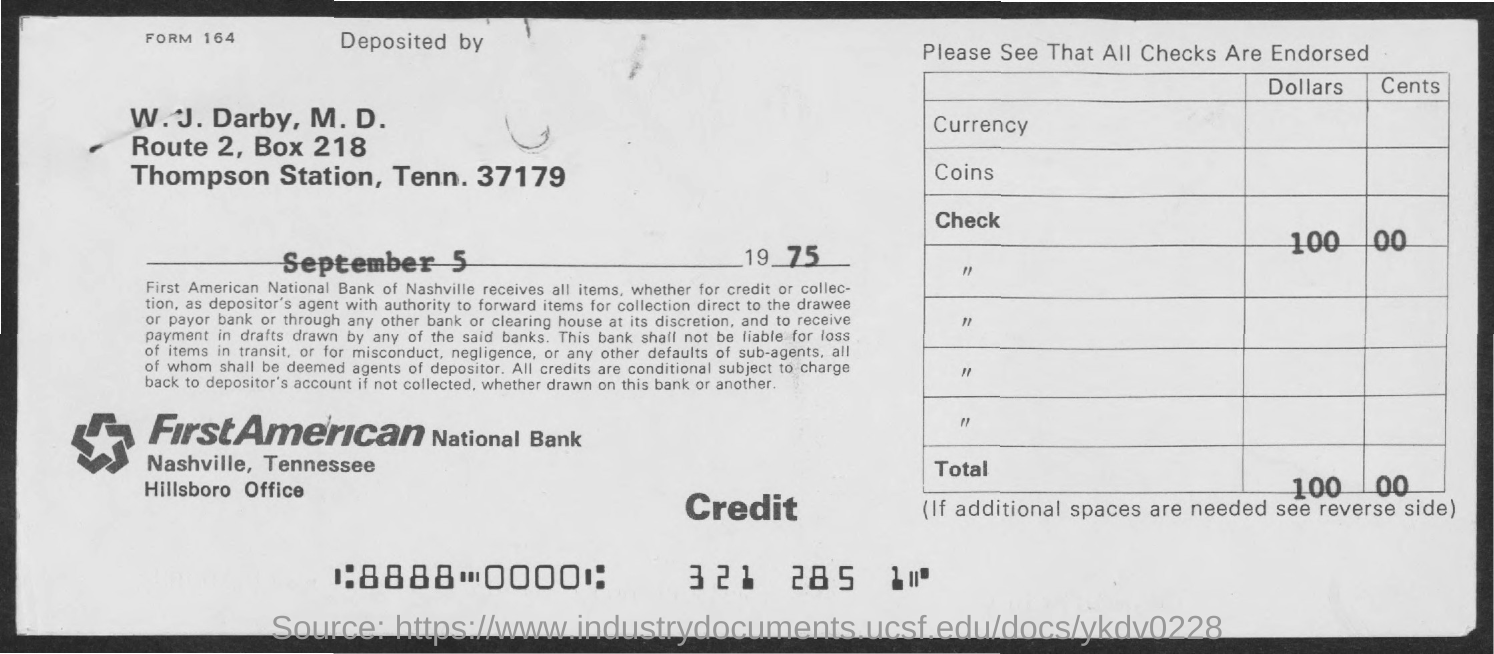What is the Form No. given here?
Your answer should be very brief. 164. Which bank has issued this check?
Your answer should be very brief. FirstAMERICAN National Bank. 